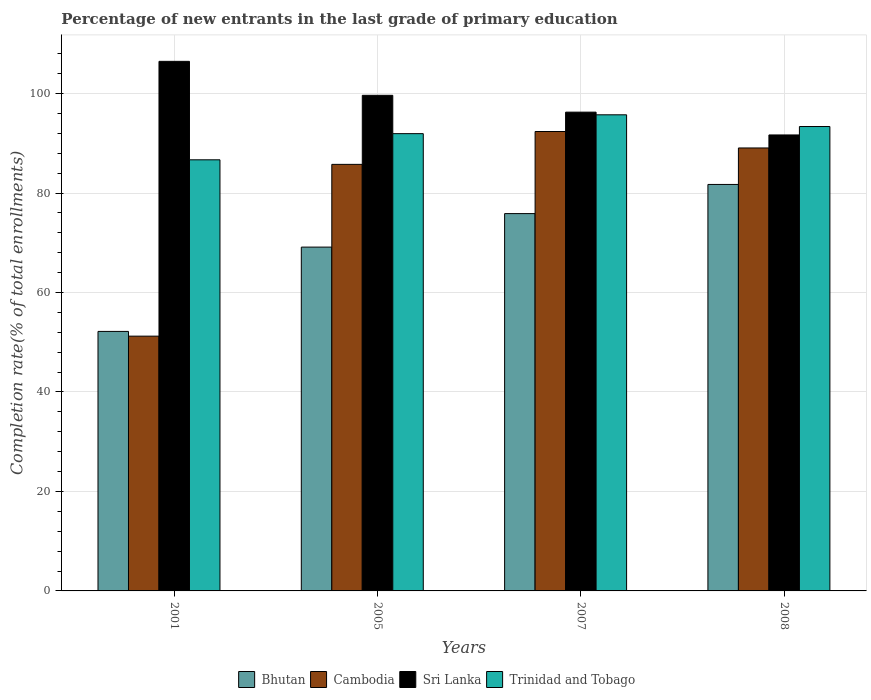How many groups of bars are there?
Keep it short and to the point. 4. How many bars are there on the 2nd tick from the left?
Offer a very short reply. 4. What is the label of the 1st group of bars from the left?
Provide a short and direct response. 2001. In how many cases, is the number of bars for a given year not equal to the number of legend labels?
Your response must be concise. 0. What is the percentage of new entrants in Bhutan in 2005?
Make the answer very short. 69.12. Across all years, what is the maximum percentage of new entrants in Sri Lanka?
Your answer should be very brief. 106.47. Across all years, what is the minimum percentage of new entrants in Bhutan?
Give a very brief answer. 52.17. In which year was the percentage of new entrants in Bhutan maximum?
Provide a succinct answer. 2008. In which year was the percentage of new entrants in Bhutan minimum?
Your answer should be compact. 2001. What is the total percentage of new entrants in Cambodia in the graph?
Ensure brevity in your answer.  318.4. What is the difference between the percentage of new entrants in Sri Lanka in 2001 and that in 2005?
Keep it short and to the point. 6.83. What is the difference between the percentage of new entrants in Sri Lanka in 2008 and the percentage of new entrants in Cambodia in 2005?
Provide a short and direct response. 5.91. What is the average percentage of new entrants in Bhutan per year?
Your answer should be compact. 69.72. In the year 2008, what is the difference between the percentage of new entrants in Cambodia and percentage of new entrants in Trinidad and Tobago?
Give a very brief answer. -4.31. What is the ratio of the percentage of new entrants in Bhutan in 2001 to that in 2008?
Your response must be concise. 0.64. What is the difference between the highest and the second highest percentage of new entrants in Cambodia?
Your answer should be very brief. 3.31. What is the difference between the highest and the lowest percentage of new entrants in Cambodia?
Offer a very short reply. 41.14. In how many years, is the percentage of new entrants in Bhutan greater than the average percentage of new entrants in Bhutan taken over all years?
Provide a short and direct response. 2. Is it the case that in every year, the sum of the percentage of new entrants in Cambodia and percentage of new entrants in Sri Lanka is greater than the sum of percentage of new entrants in Bhutan and percentage of new entrants in Trinidad and Tobago?
Offer a very short reply. No. What does the 1st bar from the left in 2007 represents?
Offer a terse response. Bhutan. What does the 2nd bar from the right in 2005 represents?
Your answer should be very brief. Sri Lanka. Is it the case that in every year, the sum of the percentage of new entrants in Cambodia and percentage of new entrants in Trinidad and Tobago is greater than the percentage of new entrants in Bhutan?
Keep it short and to the point. Yes. How many bars are there?
Give a very brief answer. 16. Are all the bars in the graph horizontal?
Provide a short and direct response. No. Does the graph contain any zero values?
Your answer should be very brief. No. Does the graph contain grids?
Provide a succinct answer. Yes. Where does the legend appear in the graph?
Offer a terse response. Bottom center. How many legend labels are there?
Offer a terse response. 4. How are the legend labels stacked?
Give a very brief answer. Horizontal. What is the title of the graph?
Give a very brief answer. Percentage of new entrants in the last grade of primary education. What is the label or title of the Y-axis?
Provide a short and direct response. Completion rate(% of total enrollments). What is the Completion rate(% of total enrollments) of Bhutan in 2001?
Offer a terse response. 52.17. What is the Completion rate(% of total enrollments) of Cambodia in 2001?
Keep it short and to the point. 51.22. What is the Completion rate(% of total enrollments) of Sri Lanka in 2001?
Offer a very short reply. 106.47. What is the Completion rate(% of total enrollments) of Trinidad and Tobago in 2001?
Provide a short and direct response. 86.67. What is the Completion rate(% of total enrollments) in Bhutan in 2005?
Provide a short and direct response. 69.12. What is the Completion rate(% of total enrollments) of Cambodia in 2005?
Provide a succinct answer. 85.76. What is the Completion rate(% of total enrollments) in Sri Lanka in 2005?
Give a very brief answer. 99.64. What is the Completion rate(% of total enrollments) of Trinidad and Tobago in 2005?
Keep it short and to the point. 91.93. What is the Completion rate(% of total enrollments) of Bhutan in 2007?
Your response must be concise. 75.86. What is the Completion rate(% of total enrollments) of Cambodia in 2007?
Keep it short and to the point. 92.36. What is the Completion rate(% of total enrollments) of Sri Lanka in 2007?
Ensure brevity in your answer.  96.26. What is the Completion rate(% of total enrollments) of Trinidad and Tobago in 2007?
Give a very brief answer. 95.72. What is the Completion rate(% of total enrollments) in Bhutan in 2008?
Offer a very short reply. 81.72. What is the Completion rate(% of total enrollments) of Cambodia in 2008?
Your response must be concise. 89.06. What is the Completion rate(% of total enrollments) in Sri Lanka in 2008?
Make the answer very short. 91.67. What is the Completion rate(% of total enrollments) of Trinidad and Tobago in 2008?
Provide a succinct answer. 93.37. Across all years, what is the maximum Completion rate(% of total enrollments) of Bhutan?
Give a very brief answer. 81.72. Across all years, what is the maximum Completion rate(% of total enrollments) of Cambodia?
Offer a terse response. 92.36. Across all years, what is the maximum Completion rate(% of total enrollments) of Sri Lanka?
Make the answer very short. 106.47. Across all years, what is the maximum Completion rate(% of total enrollments) of Trinidad and Tobago?
Your response must be concise. 95.72. Across all years, what is the minimum Completion rate(% of total enrollments) of Bhutan?
Your response must be concise. 52.17. Across all years, what is the minimum Completion rate(% of total enrollments) in Cambodia?
Provide a short and direct response. 51.22. Across all years, what is the minimum Completion rate(% of total enrollments) of Sri Lanka?
Keep it short and to the point. 91.67. Across all years, what is the minimum Completion rate(% of total enrollments) in Trinidad and Tobago?
Offer a very short reply. 86.67. What is the total Completion rate(% of total enrollments) of Bhutan in the graph?
Offer a very short reply. 278.88. What is the total Completion rate(% of total enrollments) of Cambodia in the graph?
Your answer should be compact. 318.4. What is the total Completion rate(% of total enrollments) of Sri Lanka in the graph?
Make the answer very short. 394.04. What is the total Completion rate(% of total enrollments) in Trinidad and Tobago in the graph?
Keep it short and to the point. 367.7. What is the difference between the Completion rate(% of total enrollments) of Bhutan in 2001 and that in 2005?
Your response must be concise. -16.95. What is the difference between the Completion rate(% of total enrollments) in Cambodia in 2001 and that in 2005?
Make the answer very short. -34.54. What is the difference between the Completion rate(% of total enrollments) in Sri Lanka in 2001 and that in 2005?
Offer a terse response. 6.83. What is the difference between the Completion rate(% of total enrollments) of Trinidad and Tobago in 2001 and that in 2005?
Make the answer very short. -5.26. What is the difference between the Completion rate(% of total enrollments) of Bhutan in 2001 and that in 2007?
Keep it short and to the point. -23.69. What is the difference between the Completion rate(% of total enrollments) in Cambodia in 2001 and that in 2007?
Your response must be concise. -41.14. What is the difference between the Completion rate(% of total enrollments) in Sri Lanka in 2001 and that in 2007?
Ensure brevity in your answer.  10.21. What is the difference between the Completion rate(% of total enrollments) of Trinidad and Tobago in 2001 and that in 2007?
Your response must be concise. -9.05. What is the difference between the Completion rate(% of total enrollments) of Bhutan in 2001 and that in 2008?
Your answer should be very brief. -29.55. What is the difference between the Completion rate(% of total enrollments) in Cambodia in 2001 and that in 2008?
Ensure brevity in your answer.  -37.84. What is the difference between the Completion rate(% of total enrollments) in Sri Lanka in 2001 and that in 2008?
Your answer should be compact. 14.8. What is the difference between the Completion rate(% of total enrollments) in Trinidad and Tobago in 2001 and that in 2008?
Make the answer very short. -6.69. What is the difference between the Completion rate(% of total enrollments) of Bhutan in 2005 and that in 2007?
Keep it short and to the point. -6.74. What is the difference between the Completion rate(% of total enrollments) of Cambodia in 2005 and that in 2007?
Provide a short and direct response. -6.61. What is the difference between the Completion rate(% of total enrollments) in Sri Lanka in 2005 and that in 2007?
Your answer should be compact. 3.38. What is the difference between the Completion rate(% of total enrollments) of Trinidad and Tobago in 2005 and that in 2007?
Your answer should be very brief. -3.79. What is the difference between the Completion rate(% of total enrollments) of Bhutan in 2005 and that in 2008?
Your answer should be compact. -12.6. What is the difference between the Completion rate(% of total enrollments) in Cambodia in 2005 and that in 2008?
Your answer should be compact. -3.3. What is the difference between the Completion rate(% of total enrollments) in Sri Lanka in 2005 and that in 2008?
Keep it short and to the point. 7.97. What is the difference between the Completion rate(% of total enrollments) of Trinidad and Tobago in 2005 and that in 2008?
Your answer should be very brief. -1.43. What is the difference between the Completion rate(% of total enrollments) in Bhutan in 2007 and that in 2008?
Give a very brief answer. -5.86. What is the difference between the Completion rate(% of total enrollments) in Cambodia in 2007 and that in 2008?
Ensure brevity in your answer.  3.31. What is the difference between the Completion rate(% of total enrollments) of Sri Lanka in 2007 and that in 2008?
Offer a terse response. 4.58. What is the difference between the Completion rate(% of total enrollments) of Trinidad and Tobago in 2007 and that in 2008?
Provide a short and direct response. 2.36. What is the difference between the Completion rate(% of total enrollments) in Bhutan in 2001 and the Completion rate(% of total enrollments) in Cambodia in 2005?
Your answer should be very brief. -33.58. What is the difference between the Completion rate(% of total enrollments) of Bhutan in 2001 and the Completion rate(% of total enrollments) of Sri Lanka in 2005?
Make the answer very short. -47.47. What is the difference between the Completion rate(% of total enrollments) in Bhutan in 2001 and the Completion rate(% of total enrollments) in Trinidad and Tobago in 2005?
Your response must be concise. -39.76. What is the difference between the Completion rate(% of total enrollments) in Cambodia in 2001 and the Completion rate(% of total enrollments) in Sri Lanka in 2005?
Your response must be concise. -48.42. What is the difference between the Completion rate(% of total enrollments) of Cambodia in 2001 and the Completion rate(% of total enrollments) of Trinidad and Tobago in 2005?
Provide a succinct answer. -40.71. What is the difference between the Completion rate(% of total enrollments) of Sri Lanka in 2001 and the Completion rate(% of total enrollments) of Trinidad and Tobago in 2005?
Keep it short and to the point. 14.54. What is the difference between the Completion rate(% of total enrollments) of Bhutan in 2001 and the Completion rate(% of total enrollments) of Cambodia in 2007?
Your answer should be compact. -40.19. What is the difference between the Completion rate(% of total enrollments) of Bhutan in 2001 and the Completion rate(% of total enrollments) of Sri Lanka in 2007?
Your answer should be very brief. -44.08. What is the difference between the Completion rate(% of total enrollments) of Bhutan in 2001 and the Completion rate(% of total enrollments) of Trinidad and Tobago in 2007?
Keep it short and to the point. -43.55. What is the difference between the Completion rate(% of total enrollments) in Cambodia in 2001 and the Completion rate(% of total enrollments) in Sri Lanka in 2007?
Ensure brevity in your answer.  -45.04. What is the difference between the Completion rate(% of total enrollments) in Cambodia in 2001 and the Completion rate(% of total enrollments) in Trinidad and Tobago in 2007?
Your response must be concise. -44.5. What is the difference between the Completion rate(% of total enrollments) of Sri Lanka in 2001 and the Completion rate(% of total enrollments) of Trinidad and Tobago in 2007?
Your answer should be very brief. 10.75. What is the difference between the Completion rate(% of total enrollments) in Bhutan in 2001 and the Completion rate(% of total enrollments) in Cambodia in 2008?
Offer a very short reply. -36.88. What is the difference between the Completion rate(% of total enrollments) of Bhutan in 2001 and the Completion rate(% of total enrollments) of Sri Lanka in 2008?
Keep it short and to the point. -39.5. What is the difference between the Completion rate(% of total enrollments) of Bhutan in 2001 and the Completion rate(% of total enrollments) of Trinidad and Tobago in 2008?
Offer a terse response. -41.19. What is the difference between the Completion rate(% of total enrollments) of Cambodia in 2001 and the Completion rate(% of total enrollments) of Sri Lanka in 2008?
Your answer should be compact. -40.45. What is the difference between the Completion rate(% of total enrollments) in Cambodia in 2001 and the Completion rate(% of total enrollments) in Trinidad and Tobago in 2008?
Offer a very short reply. -42.14. What is the difference between the Completion rate(% of total enrollments) of Sri Lanka in 2001 and the Completion rate(% of total enrollments) of Trinidad and Tobago in 2008?
Ensure brevity in your answer.  13.1. What is the difference between the Completion rate(% of total enrollments) in Bhutan in 2005 and the Completion rate(% of total enrollments) in Cambodia in 2007?
Your answer should be very brief. -23.24. What is the difference between the Completion rate(% of total enrollments) in Bhutan in 2005 and the Completion rate(% of total enrollments) in Sri Lanka in 2007?
Give a very brief answer. -27.13. What is the difference between the Completion rate(% of total enrollments) in Bhutan in 2005 and the Completion rate(% of total enrollments) in Trinidad and Tobago in 2007?
Ensure brevity in your answer.  -26.6. What is the difference between the Completion rate(% of total enrollments) of Cambodia in 2005 and the Completion rate(% of total enrollments) of Sri Lanka in 2007?
Provide a short and direct response. -10.5. What is the difference between the Completion rate(% of total enrollments) of Cambodia in 2005 and the Completion rate(% of total enrollments) of Trinidad and Tobago in 2007?
Offer a terse response. -9.96. What is the difference between the Completion rate(% of total enrollments) in Sri Lanka in 2005 and the Completion rate(% of total enrollments) in Trinidad and Tobago in 2007?
Ensure brevity in your answer.  3.92. What is the difference between the Completion rate(% of total enrollments) in Bhutan in 2005 and the Completion rate(% of total enrollments) in Cambodia in 2008?
Offer a very short reply. -19.93. What is the difference between the Completion rate(% of total enrollments) in Bhutan in 2005 and the Completion rate(% of total enrollments) in Sri Lanka in 2008?
Make the answer very short. -22.55. What is the difference between the Completion rate(% of total enrollments) of Bhutan in 2005 and the Completion rate(% of total enrollments) of Trinidad and Tobago in 2008?
Your answer should be very brief. -24.24. What is the difference between the Completion rate(% of total enrollments) of Cambodia in 2005 and the Completion rate(% of total enrollments) of Sri Lanka in 2008?
Ensure brevity in your answer.  -5.91. What is the difference between the Completion rate(% of total enrollments) of Cambodia in 2005 and the Completion rate(% of total enrollments) of Trinidad and Tobago in 2008?
Give a very brief answer. -7.61. What is the difference between the Completion rate(% of total enrollments) in Sri Lanka in 2005 and the Completion rate(% of total enrollments) in Trinidad and Tobago in 2008?
Your response must be concise. 6.27. What is the difference between the Completion rate(% of total enrollments) of Bhutan in 2007 and the Completion rate(% of total enrollments) of Cambodia in 2008?
Keep it short and to the point. -13.2. What is the difference between the Completion rate(% of total enrollments) in Bhutan in 2007 and the Completion rate(% of total enrollments) in Sri Lanka in 2008?
Make the answer very short. -15.81. What is the difference between the Completion rate(% of total enrollments) of Bhutan in 2007 and the Completion rate(% of total enrollments) of Trinidad and Tobago in 2008?
Your answer should be very brief. -17.5. What is the difference between the Completion rate(% of total enrollments) of Cambodia in 2007 and the Completion rate(% of total enrollments) of Sri Lanka in 2008?
Provide a short and direct response. 0.69. What is the difference between the Completion rate(% of total enrollments) of Cambodia in 2007 and the Completion rate(% of total enrollments) of Trinidad and Tobago in 2008?
Ensure brevity in your answer.  -1. What is the difference between the Completion rate(% of total enrollments) of Sri Lanka in 2007 and the Completion rate(% of total enrollments) of Trinidad and Tobago in 2008?
Your response must be concise. 2.89. What is the average Completion rate(% of total enrollments) in Bhutan per year?
Provide a short and direct response. 69.72. What is the average Completion rate(% of total enrollments) of Cambodia per year?
Your answer should be compact. 79.6. What is the average Completion rate(% of total enrollments) of Sri Lanka per year?
Ensure brevity in your answer.  98.51. What is the average Completion rate(% of total enrollments) in Trinidad and Tobago per year?
Provide a short and direct response. 91.92. In the year 2001, what is the difference between the Completion rate(% of total enrollments) of Bhutan and Completion rate(% of total enrollments) of Cambodia?
Make the answer very short. 0.95. In the year 2001, what is the difference between the Completion rate(% of total enrollments) in Bhutan and Completion rate(% of total enrollments) in Sri Lanka?
Make the answer very short. -54.3. In the year 2001, what is the difference between the Completion rate(% of total enrollments) of Bhutan and Completion rate(% of total enrollments) of Trinidad and Tobago?
Provide a succinct answer. -34.5. In the year 2001, what is the difference between the Completion rate(% of total enrollments) of Cambodia and Completion rate(% of total enrollments) of Sri Lanka?
Your answer should be compact. -55.25. In the year 2001, what is the difference between the Completion rate(% of total enrollments) in Cambodia and Completion rate(% of total enrollments) in Trinidad and Tobago?
Make the answer very short. -35.45. In the year 2001, what is the difference between the Completion rate(% of total enrollments) of Sri Lanka and Completion rate(% of total enrollments) of Trinidad and Tobago?
Offer a very short reply. 19.8. In the year 2005, what is the difference between the Completion rate(% of total enrollments) of Bhutan and Completion rate(% of total enrollments) of Cambodia?
Provide a short and direct response. -16.64. In the year 2005, what is the difference between the Completion rate(% of total enrollments) of Bhutan and Completion rate(% of total enrollments) of Sri Lanka?
Your answer should be very brief. -30.52. In the year 2005, what is the difference between the Completion rate(% of total enrollments) in Bhutan and Completion rate(% of total enrollments) in Trinidad and Tobago?
Your response must be concise. -22.81. In the year 2005, what is the difference between the Completion rate(% of total enrollments) of Cambodia and Completion rate(% of total enrollments) of Sri Lanka?
Offer a very short reply. -13.88. In the year 2005, what is the difference between the Completion rate(% of total enrollments) of Cambodia and Completion rate(% of total enrollments) of Trinidad and Tobago?
Make the answer very short. -6.18. In the year 2005, what is the difference between the Completion rate(% of total enrollments) of Sri Lanka and Completion rate(% of total enrollments) of Trinidad and Tobago?
Provide a short and direct response. 7.71. In the year 2007, what is the difference between the Completion rate(% of total enrollments) of Bhutan and Completion rate(% of total enrollments) of Cambodia?
Your answer should be compact. -16.5. In the year 2007, what is the difference between the Completion rate(% of total enrollments) of Bhutan and Completion rate(% of total enrollments) of Sri Lanka?
Give a very brief answer. -20.4. In the year 2007, what is the difference between the Completion rate(% of total enrollments) of Bhutan and Completion rate(% of total enrollments) of Trinidad and Tobago?
Give a very brief answer. -19.86. In the year 2007, what is the difference between the Completion rate(% of total enrollments) in Cambodia and Completion rate(% of total enrollments) in Sri Lanka?
Offer a very short reply. -3.89. In the year 2007, what is the difference between the Completion rate(% of total enrollments) of Cambodia and Completion rate(% of total enrollments) of Trinidad and Tobago?
Provide a succinct answer. -3.36. In the year 2007, what is the difference between the Completion rate(% of total enrollments) in Sri Lanka and Completion rate(% of total enrollments) in Trinidad and Tobago?
Provide a short and direct response. 0.53. In the year 2008, what is the difference between the Completion rate(% of total enrollments) of Bhutan and Completion rate(% of total enrollments) of Cambodia?
Offer a very short reply. -7.33. In the year 2008, what is the difference between the Completion rate(% of total enrollments) of Bhutan and Completion rate(% of total enrollments) of Sri Lanka?
Your answer should be compact. -9.95. In the year 2008, what is the difference between the Completion rate(% of total enrollments) in Bhutan and Completion rate(% of total enrollments) in Trinidad and Tobago?
Make the answer very short. -11.64. In the year 2008, what is the difference between the Completion rate(% of total enrollments) of Cambodia and Completion rate(% of total enrollments) of Sri Lanka?
Make the answer very short. -2.62. In the year 2008, what is the difference between the Completion rate(% of total enrollments) of Cambodia and Completion rate(% of total enrollments) of Trinidad and Tobago?
Offer a terse response. -4.31. In the year 2008, what is the difference between the Completion rate(% of total enrollments) in Sri Lanka and Completion rate(% of total enrollments) in Trinidad and Tobago?
Offer a very short reply. -1.69. What is the ratio of the Completion rate(% of total enrollments) in Bhutan in 2001 to that in 2005?
Offer a terse response. 0.75. What is the ratio of the Completion rate(% of total enrollments) in Cambodia in 2001 to that in 2005?
Provide a succinct answer. 0.6. What is the ratio of the Completion rate(% of total enrollments) of Sri Lanka in 2001 to that in 2005?
Your answer should be compact. 1.07. What is the ratio of the Completion rate(% of total enrollments) in Trinidad and Tobago in 2001 to that in 2005?
Offer a terse response. 0.94. What is the ratio of the Completion rate(% of total enrollments) in Bhutan in 2001 to that in 2007?
Your response must be concise. 0.69. What is the ratio of the Completion rate(% of total enrollments) of Cambodia in 2001 to that in 2007?
Offer a very short reply. 0.55. What is the ratio of the Completion rate(% of total enrollments) of Sri Lanka in 2001 to that in 2007?
Provide a short and direct response. 1.11. What is the ratio of the Completion rate(% of total enrollments) of Trinidad and Tobago in 2001 to that in 2007?
Provide a short and direct response. 0.91. What is the ratio of the Completion rate(% of total enrollments) of Bhutan in 2001 to that in 2008?
Provide a short and direct response. 0.64. What is the ratio of the Completion rate(% of total enrollments) of Cambodia in 2001 to that in 2008?
Give a very brief answer. 0.58. What is the ratio of the Completion rate(% of total enrollments) of Sri Lanka in 2001 to that in 2008?
Your response must be concise. 1.16. What is the ratio of the Completion rate(% of total enrollments) of Trinidad and Tobago in 2001 to that in 2008?
Offer a very short reply. 0.93. What is the ratio of the Completion rate(% of total enrollments) of Bhutan in 2005 to that in 2007?
Provide a short and direct response. 0.91. What is the ratio of the Completion rate(% of total enrollments) in Cambodia in 2005 to that in 2007?
Keep it short and to the point. 0.93. What is the ratio of the Completion rate(% of total enrollments) in Sri Lanka in 2005 to that in 2007?
Offer a very short reply. 1.04. What is the ratio of the Completion rate(% of total enrollments) in Trinidad and Tobago in 2005 to that in 2007?
Give a very brief answer. 0.96. What is the ratio of the Completion rate(% of total enrollments) in Bhutan in 2005 to that in 2008?
Give a very brief answer. 0.85. What is the ratio of the Completion rate(% of total enrollments) in Cambodia in 2005 to that in 2008?
Make the answer very short. 0.96. What is the ratio of the Completion rate(% of total enrollments) of Sri Lanka in 2005 to that in 2008?
Your response must be concise. 1.09. What is the ratio of the Completion rate(% of total enrollments) of Trinidad and Tobago in 2005 to that in 2008?
Ensure brevity in your answer.  0.98. What is the ratio of the Completion rate(% of total enrollments) in Bhutan in 2007 to that in 2008?
Keep it short and to the point. 0.93. What is the ratio of the Completion rate(% of total enrollments) in Cambodia in 2007 to that in 2008?
Provide a short and direct response. 1.04. What is the ratio of the Completion rate(% of total enrollments) in Sri Lanka in 2007 to that in 2008?
Offer a terse response. 1.05. What is the ratio of the Completion rate(% of total enrollments) in Trinidad and Tobago in 2007 to that in 2008?
Keep it short and to the point. 1.03. What is the difference between the highest and the second highest Completion rate(% of total enrollments) in Bhutan?
Make the answer very short. 5.86. What is the difference between the highest and the second highest Completion rate(% of total enrollments) of Cambodia?
Give a very brief answer. 3.31. What is the difference between the highest and the second highest Completion rate(% of total enrollments) of Sri Lanka?
Your answer should be very brief. 6.83. What is the difference between the highest and the second highest Completion rate(% of total enrollments) of Trinidad and Tobago?
Provide a succinct answer. 2.36. What is the difference between the highest and the lowest Completion rate(% of total enrollments) of Bhutan?
Ensure brevity in your answer.  29.55. What is the difference between the highest and the lowest Completion rate(% of total enrollments) in Cambodia?
Offer a very short reply. 41.14. What is the difference between the highest and the lowest Completion rate(% of total enrollments) in Sri Lanka?
Make the answer very short. 14.8. What is the difference between the highest and the lowest Completion rate(% of total enrollments) in Trinidad and Tobago?
Provide a succinct answer. 9.05. 